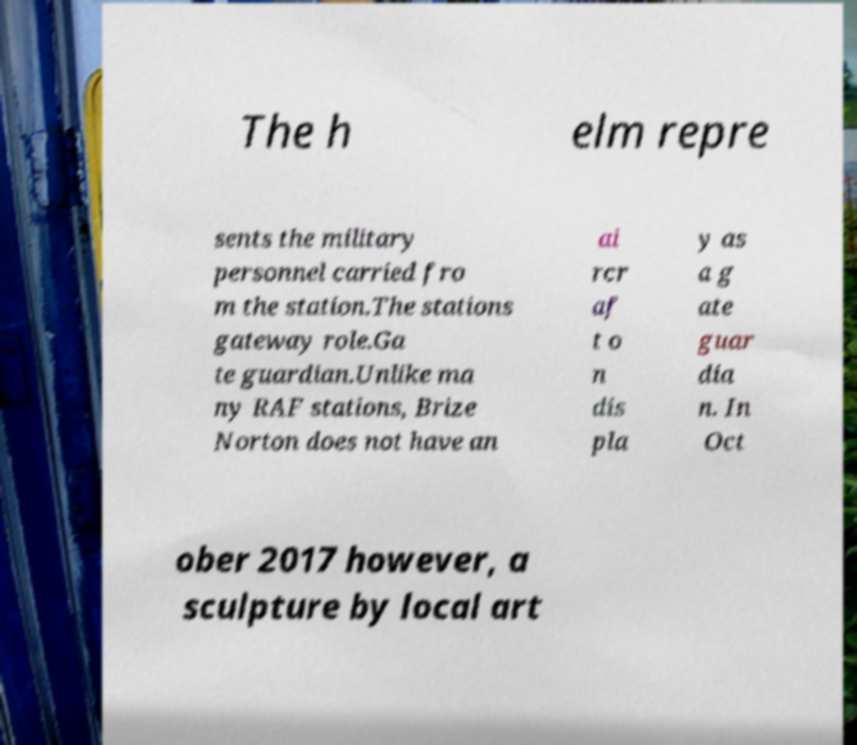I need the written content from this picture converted into text. Can you do that? The h elm repre sents the military personnel carried fro m the station.The stations gateway role.Ga te guardian.Unlike ma ny RAF stations, Brize Norton does not have an ai rcr af t o n dis pla y as a g ate guar dia n. In Oct ober 2017 however, a sculpture by local art 